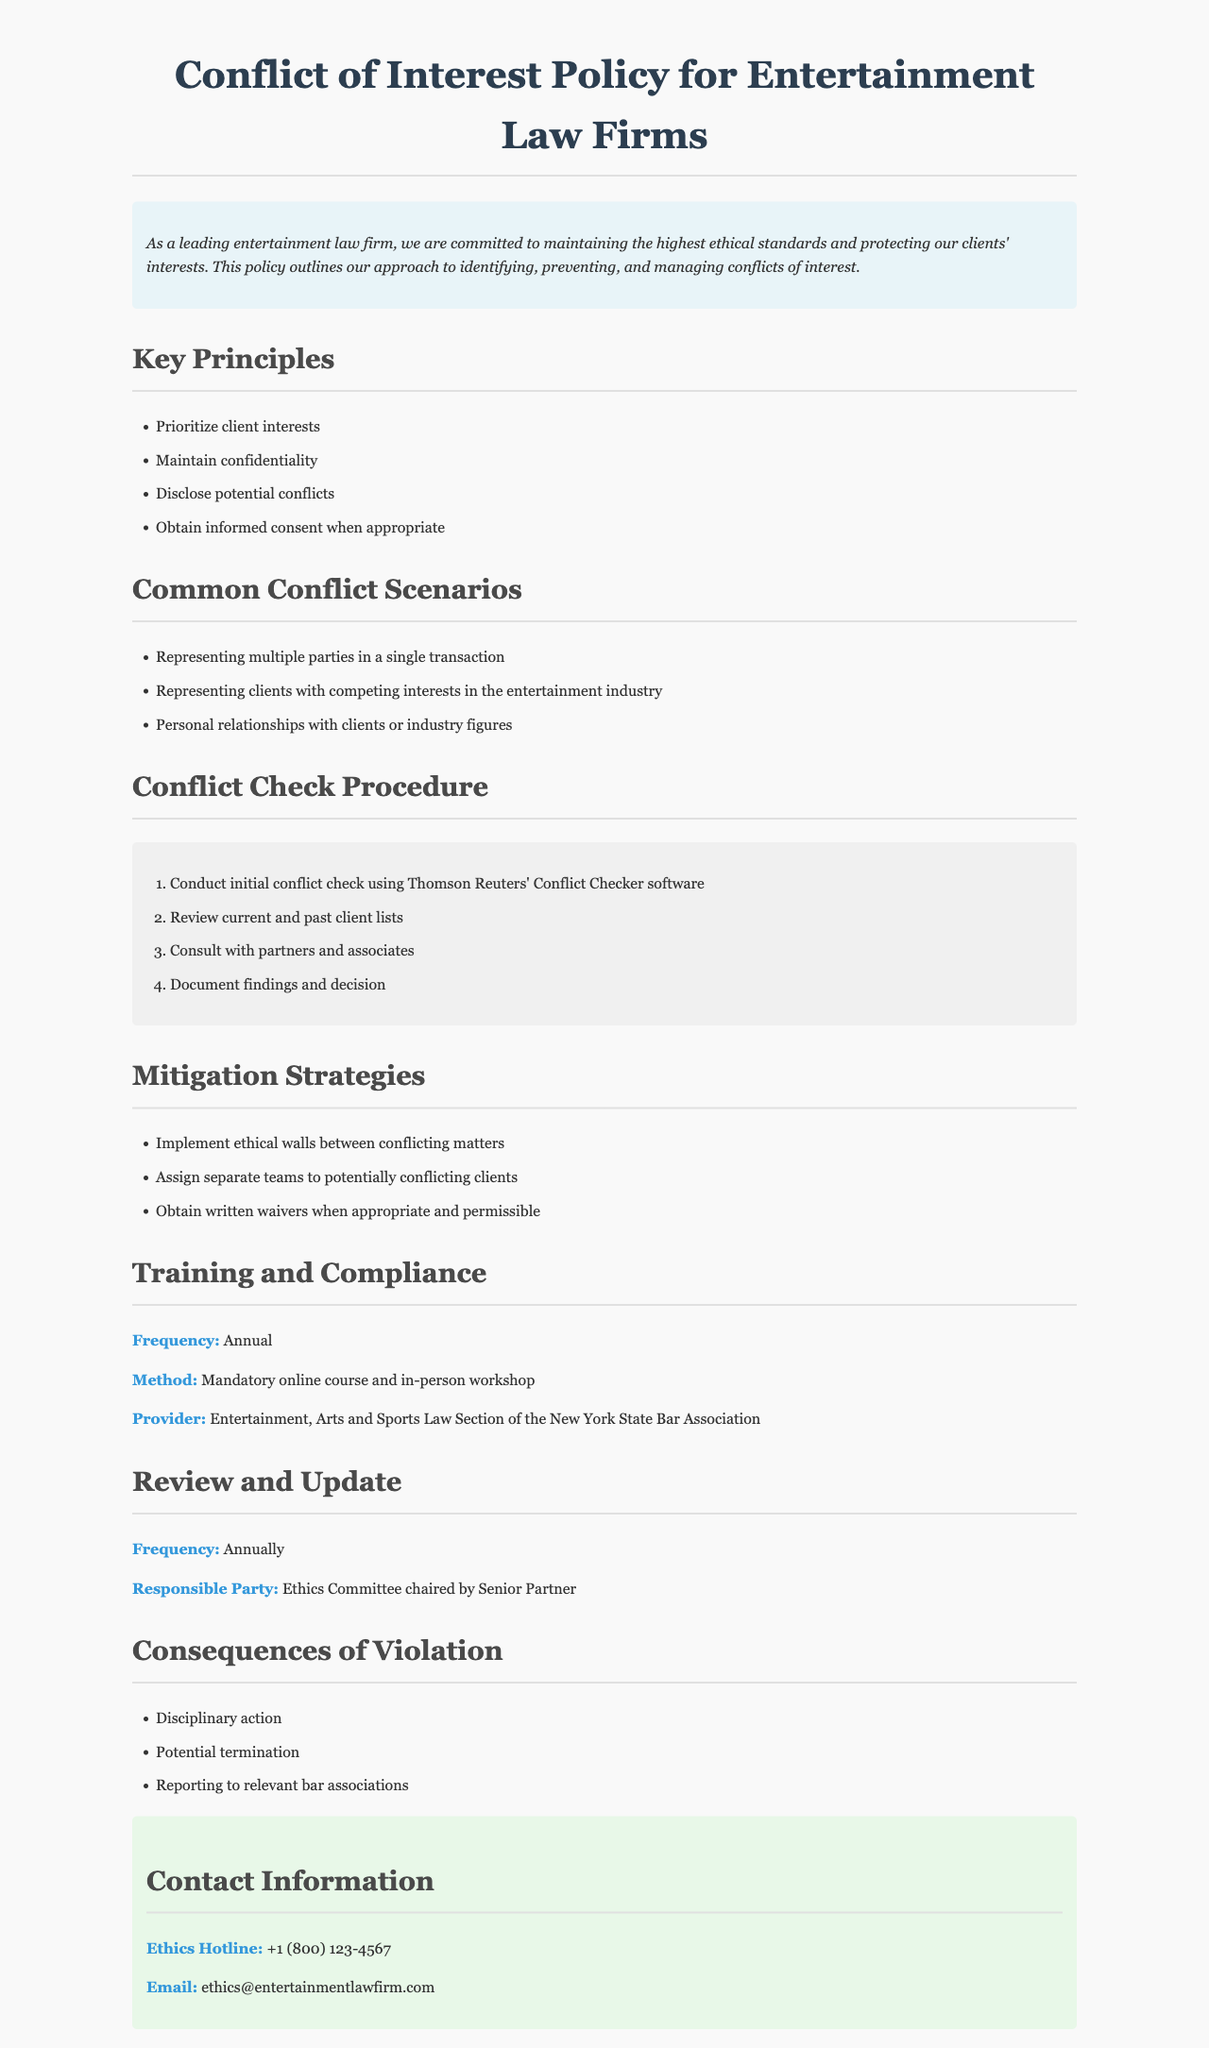What are the key principles of the policy? The key principles are outlined in the section titled "Key Principles," which lists the priorities and guidelines to follow.
Answer: Prioritize client interests, Maintain confidentiality, Disclose potential conflicts, Obtain informed consent when appropriate What training is required under this policy? The "Training and Compliance" section specifies the type of training required, including frequency and method.
Answer: Mandatory online course and in-person workshop How often is the policy reviewed and updated? The "Review and Update" section states the frequency of review for the policy, which is important for maintaining its relevance.
Answer: Annually What is one example of a common conflict scenario? The "Common Conflict Scenarios" section provides examples of situations that could lead to conflicts of interest, highlighting real-world application.
Answer: Representing multiple parties in a single transaction Who is responsible for reviewing and updating the policy? The "Review and Update" section mentions the entity responsible for overseeing the policy's maintenance.
Answer: Ethics Committee chaired by Senior Partner What are possible consequences of a violation of this policy? The "Consequences of Violation" section details repercussions for failing to adhere to the policy, ensuring accountability.
Answer: Disciplinary action, Potential termination, Reporting to relevant bar associations What is the contact number for the Ethics Hotline? The contact information section provides specific details for reaching out regarding ethics concerns, which is crucial for compliance.
Answer: +1 (800) 123-4567 What software is used for the initial conflict check? The "Conflict Check Procedure" lists the tools involved in identifying conflicts, which is vital for proper adherence to the policy.
Answer: Thomson Reuters' Conflict Checker software 